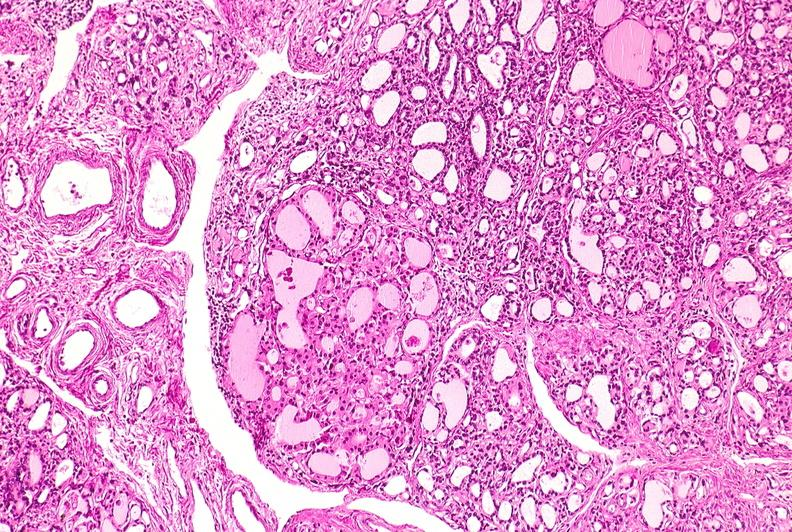what is present?
Answer the question using a single word or phrase. Endocrine 